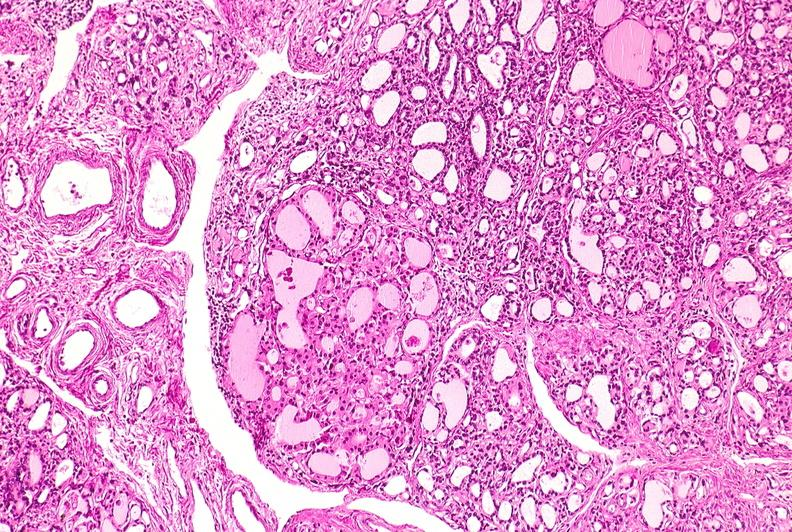what is present?
Answer the question using a single word or phrase. Endocrine 